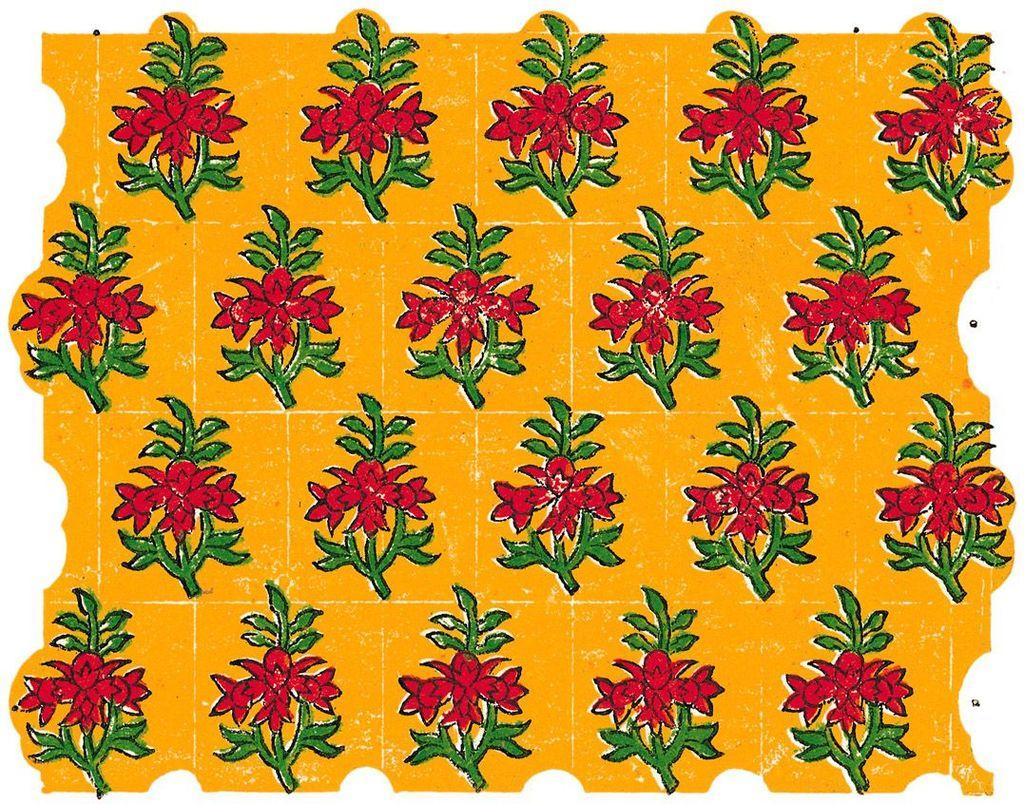What is the main design or pattern in the image? There is a flower plant design in the image. What color is the background of the image? The background of the image is yellow. What type of crayon is being used to draw the flower plant design in the image? There is no crayon present in the image, and the flower plant design is not being drawn. 